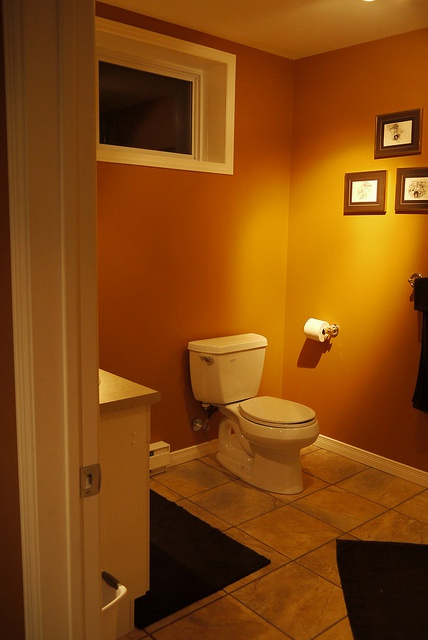Describe the objects in this image and their specific colors. I can see a toilet in black, brown, orange, and maroon tones in this image. 